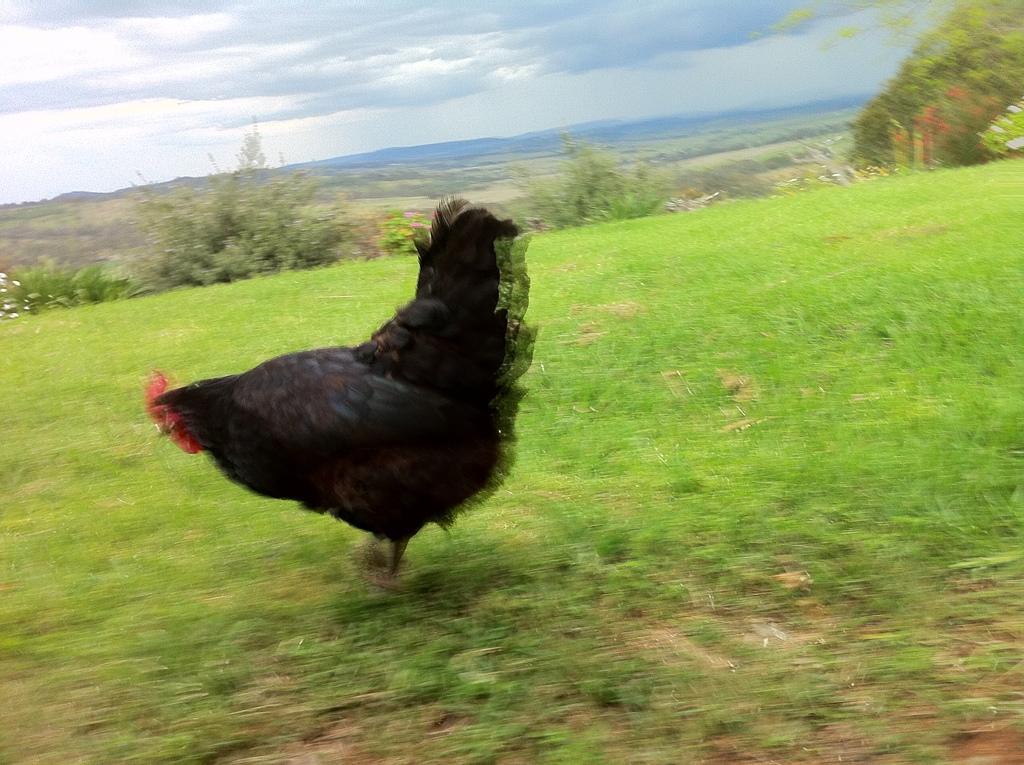Describe this image in one or two sentences. Land is covered with grass. Here we can see a hen. Background there are plants. Sky is cloudy. 